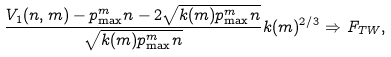Convert formula to latex. <formula><loc_0><loc_0><loc_500><loc_500>\frac { V _ { 1 } ( n , m ) - p _ { \max } ^ { m } n - 2 \sqrt { k ( m ) p _ { \max } ^ { m } n } } { \sqrt { k ( m ) p _ { \max } ^ { m } n } } k ( m ) ^ { 2 / 3 } \Rightarrow F _ { T W } ,</formula> 